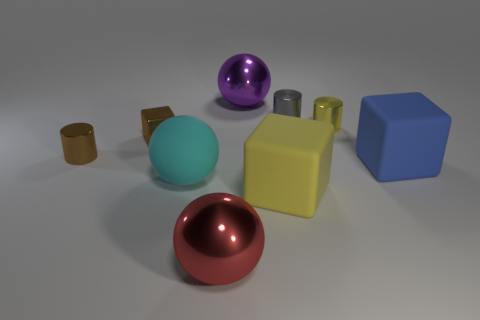Subtract all large matte cubes. How many cubes are left? 1 Subtract 3 cubes. How many cubes are left? 0 Subtract all blue cubes. How many cubes are left? 2 Subtract all cylinders. How many objects are left? 6 Subtract all red cubes. How many yellow balls are left? 0 Subtract all big blue objects. Subtract all gray shiny cylinders. How many objects are left? 7 Add 5 large purple things. How many large purple things are left? 6 Add 4 cyan balls. How many cyan balls exist? 5 Add 1 small yellow cylinders. How many objects exist? 10 Subtract 0 brown spheres. How many objects are left? 9 